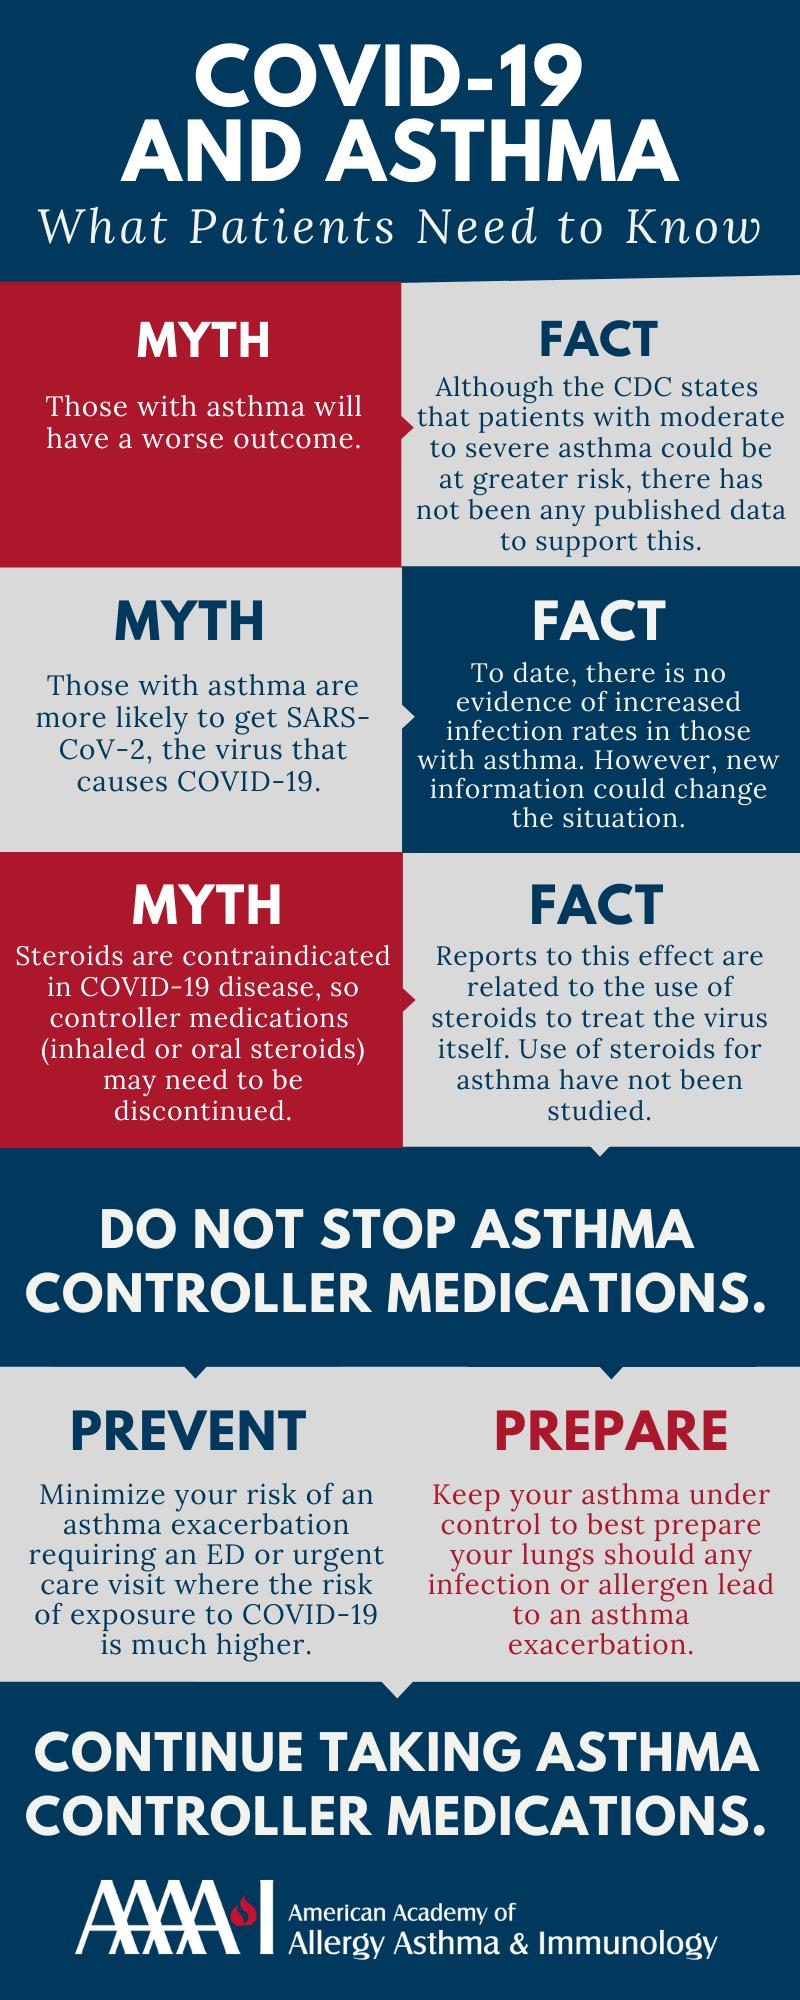Draw attention to some important aspects in this diagram. The American Academy of Allergy Asthma & Immunology infographic conveys the message that individuals with asthma should continue to take their asthma controller medications to prevent the condition from worsening. There are 3 myths listed in the infographic. 